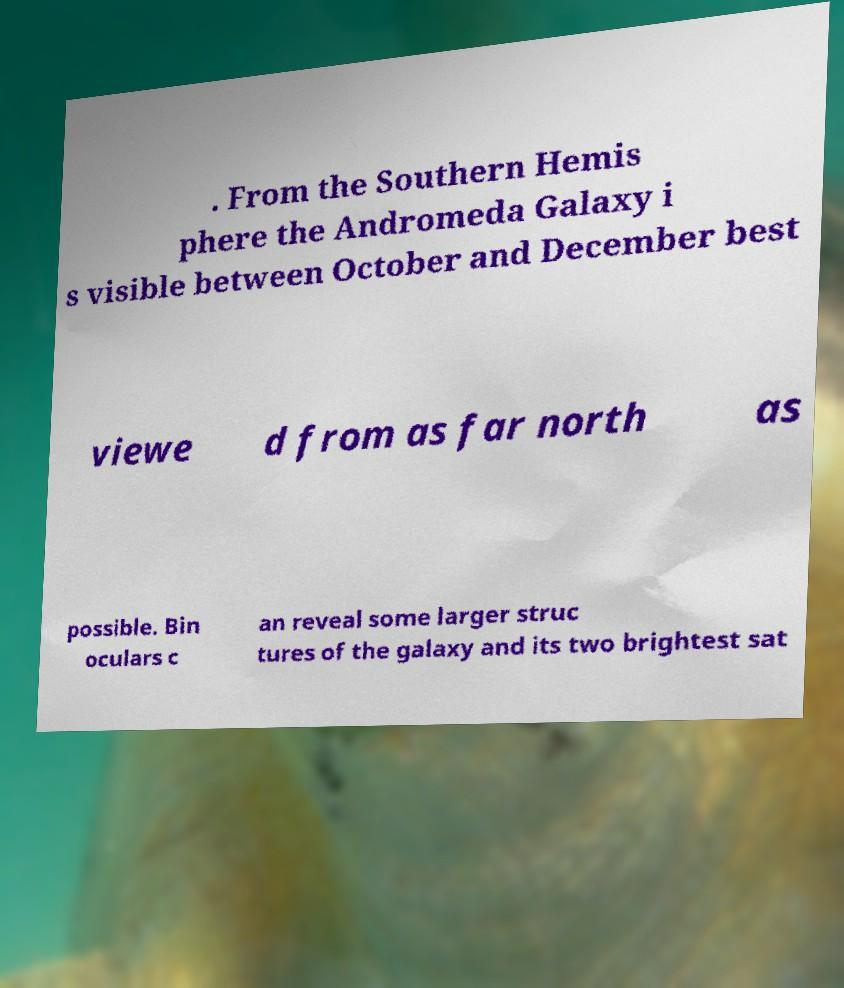I need the written content from this picture converted into text. Can you do that? . From the Southern Hemis phere the Andromeda Galaxy i s visible between October and December best viewe d from as far north as possible. Bin oculars c an reveal some larger struc tures of the galaxy and its two brightest sat 